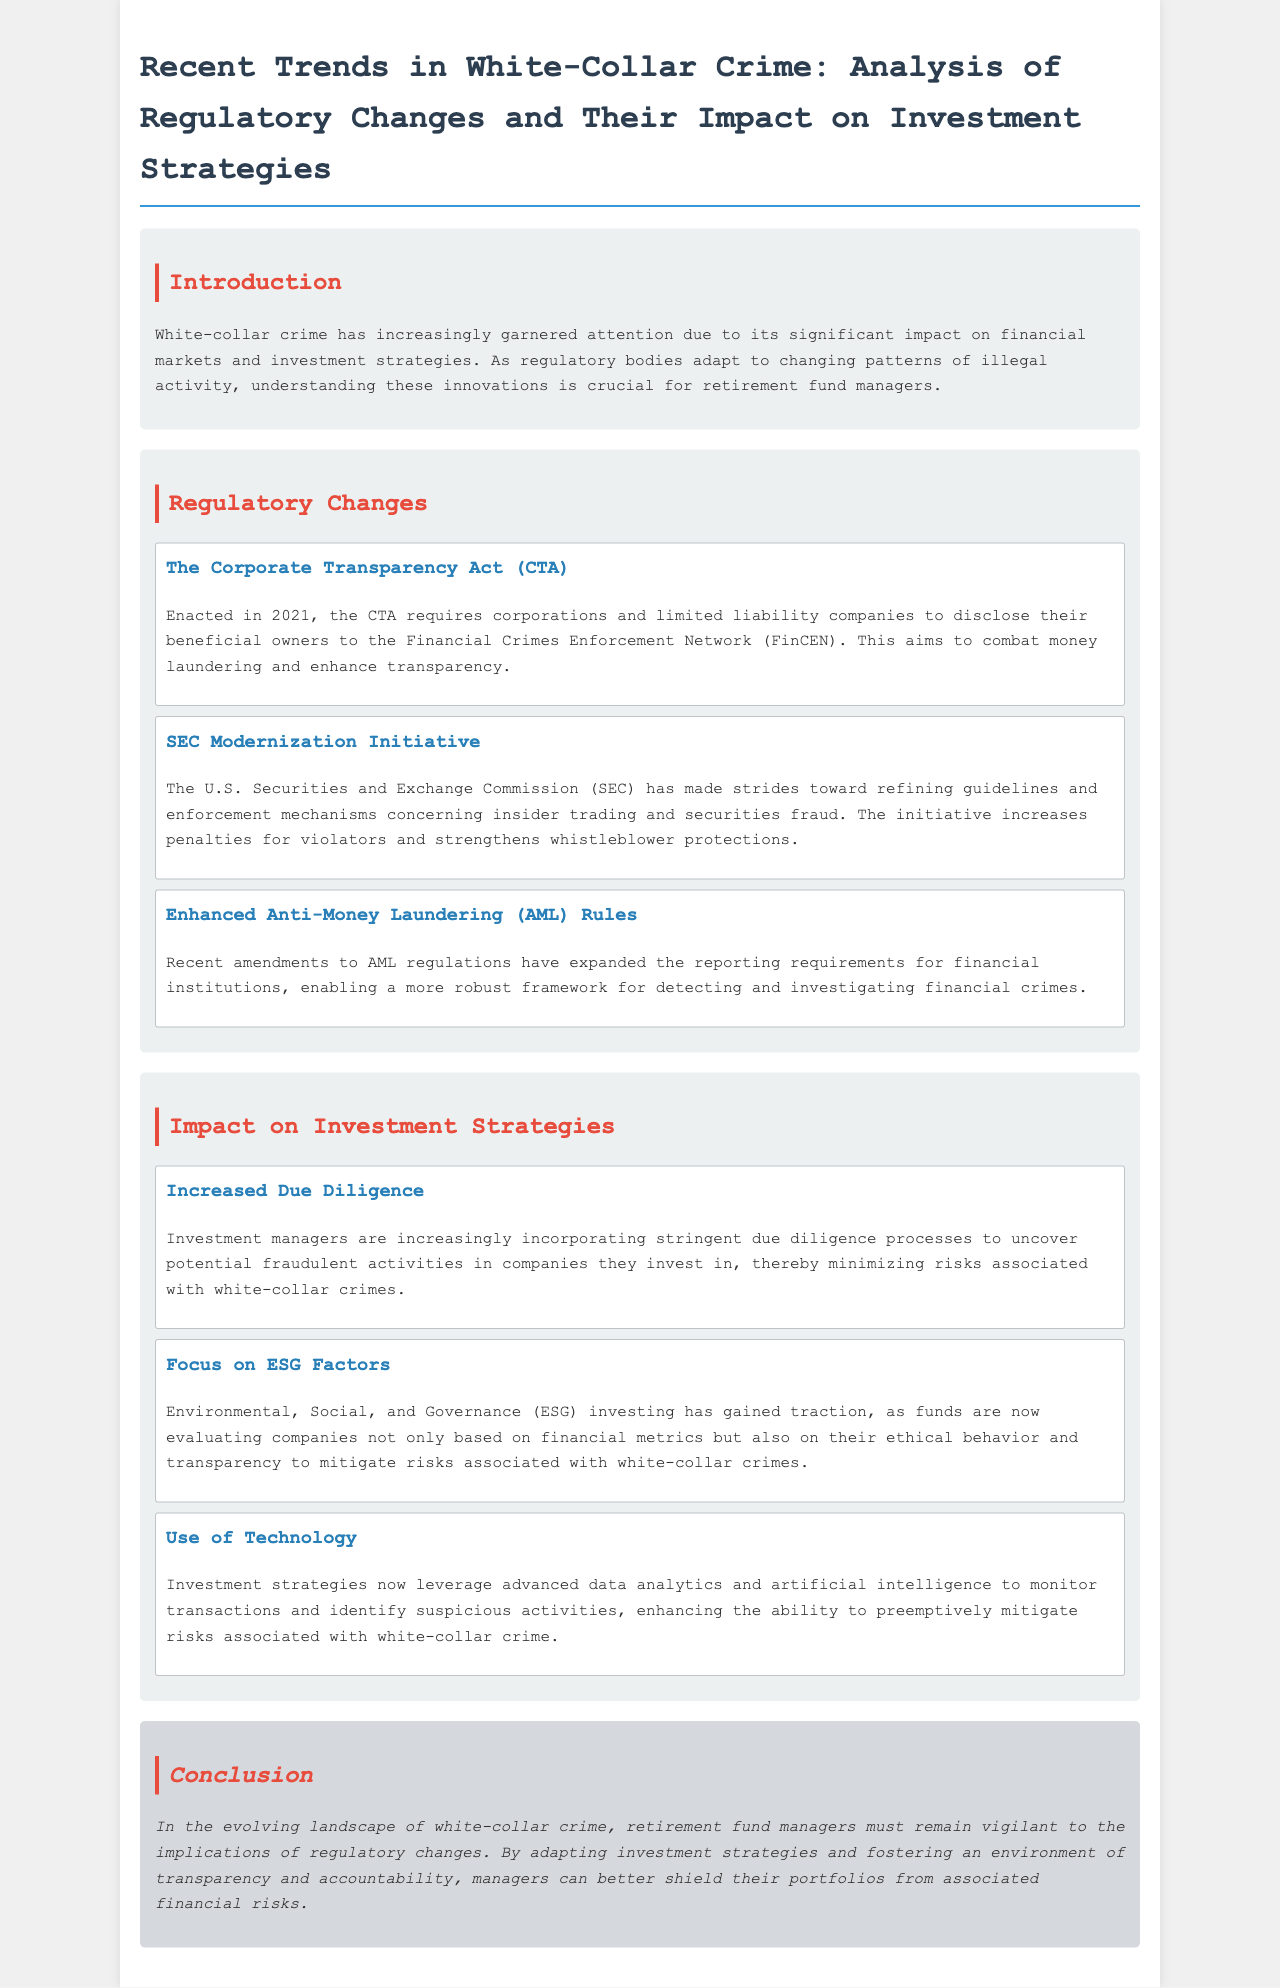What is the title of the report? The title of the report is stated at the beginning of the document.
Answer: Recent Trends in White-Collar Crime: Analysis of Regulatory Changes and Their Impact on Investment Strategies When was the Corporate Transparency Act enacted? The enactment year of the Corporate Transparency Act is mentioned in the regulatory section.
Answer: 2021 What does the SEC Modernization Initiative aim to enhance? The document specifies the goal of the SEC Modernization Initiative in relation to securities regulations.
Answer: Whistleblower protections What is a key focus of investment strategies mentioned in the document? The document discusses various investment strategies that managers are adopting in response to white-collar crime.
Answer: ESG Factors What technological approach is discussed for mitigating risks in investment strategies? The document details how technology is being utilized in investment strategies.
Answer: Advanced data analytics Which regulatory body is responsible for the Corporate Transparency Act? The document names the regulatory body that oversees compliance with the Corporate Transparency Act.
Answer: FinCEN What type of crimes are the enhanced AML rules aimed at combating? The section on regulatory changes specifies the type of crimes targeted by the enhanced AML rules.
Answer: Financial crimes What is the overall recommendation for retirement fund managers in the conclusion? The conclusion provides a strategic recommendation for managers in light of regulatory changes.
Answer: Remain vigilant 